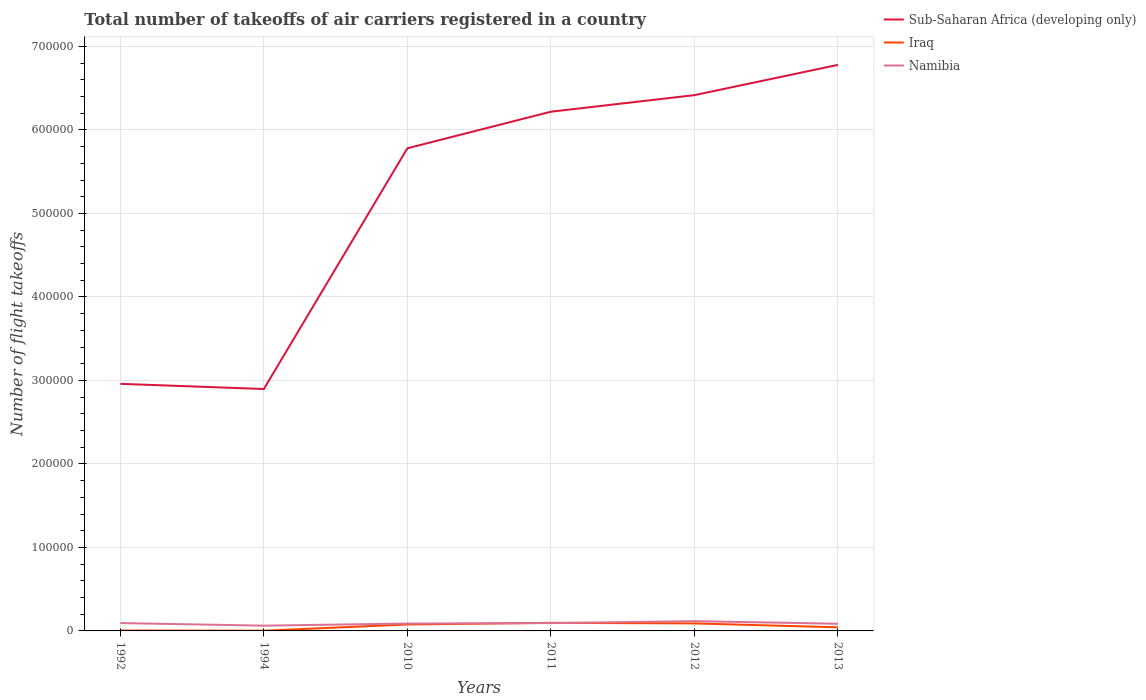How many different coloured lines are there?
Make the answer very short. 3. Across all years, what is the maximum total number of flight takeoffs in Sub-Saharan Africa (developing only)?
Ensure brevity in your answer.  2.90e+05. What is the total total number of flight takeoffs in Sub-Saharan Africa (developing only) in the graph?
Offer a terse response. -3.52e+05. What is the difference between the highest and the second highest total number of flight takeoffs in Namibia?
Offer a terse response. 5411. How many lines are there?
Make the answer very short. 3. What is the difference between two consecutive major ticks on the Y-axis?
Provide a short and direct response. 1.00e+05. Are the values on the major ticks of Y-axis written in scientific E-notation?
Your response must be concise. No. Does the graph contain any zero values?
Offer a terse response. No. Does the graph contain grids?
Your answer should be compact. Yes. Where does the legend appear in the graph?
Your answer should be compact. Top right. What is the title of the graph?
Give a very brief answer. Total number of takeoffs of air carriers registered in a country. What is the label or title of the X-axis?
Your answer should be compact. Years. What is the label or title of the Y-axis?
Give a very brief answer. Number of flight takeoffs. What is the Number of flight takeoffs of Sub-Saharan Africa (developing only) in 1992?
Provide a succinct answer. 2.96e+05. What is the Number of flight takeoffs in Iraq in 1992?
Offer a terse response. 500. What is the Number of flight takeoffs of Namibia in 1992?
Make the answer very short. 9400. What is the Number of flight takeoffs of Sub-Saharan Africa (developing only) in 1994?
Give a very brief answer. 2.90e+05. What is the Number of flight takeoffs of Iraq in 1994?
Your answer should be very brief. 300. What is the Number of flight takeoffs of Namibia in 1994?
Provide a succinct answer. 6300. What is the Number of flight takeoffs of Sub-Saharan Africa (developing only) in 2010?
Give a very brief answer. 5.78e+05. What is the Number of flight takeoffs of Iraq in 2010?
Your answer should be very brief. 7692. What is the Number of flight takeoffs of Namibia in 2010?
Your answer should be very brief. 8836. What is the Number of flight takeoffs in Sub-Saharan Africa (developing only) in 2011?
Make the answer very short. 6.22e+05. What is the Number of flight takeoffs in Iraq in 2011?
Ensure brevity in your answer.  9697. What is the Number of flight takeoffs of Namibia in 2011?
Give a very brief answer. 9400. What is the Number of flight takeoffs in Sub-Saharan Africa (developing only) in 2012?
Give a very brief answer. 6.42e+05. What is the Number of flight takeoffs of Iraq in 2012?
Provide a succinct answer. 8993. What is the Number of flight takeoffs of Namibia in 2012?
Your answer should be very brief. 1.17e+04. What is the Number of flight takeoffs of Sub-Saharan Africa (developing only) in 2013?
Provide a short and direct response. 6.78e+05. What is the Number of flight takeoffs in Iraq in 2013?
Give a very brief answer. 4320.97. What is the Number of flight takeoffs in Namibia in 2013?
Provide a short and direct response. 8571. Across all years, what is the maximum Number of flight takeoffs in Sub-Saharan Africa (developing only)?
Offer a very short reply. 6.78e+05. Across all years, what is the maximum Number of flight takeoffs in Iraq?
Offer a very short reply. 9697. Across all years, what is the maximum Number of flight takeoffs in Namibia?
Your answer should be compact. 1.17e+04. Across all years, what is the minimum Number of flight takeoffs of Sub-Saharan Africa (developing only)?
Provide a short and direct response. 2.90e+05. Across all years, what is the minimum Number of flight takeoffs in Iraq?
Provide a succinct answer. 300. Across all years, what is the minimum Number of flight takeoffs of Namibia?
Keep it short and to the point. 6300. What is the total Number of flight takeoffs of Sub-Saharan Africa (developing only) in the graph?
Give a very brief answer. 3.10e+06. What is the total Number of flight takeoffs in Iraq in the graph?
Keep it short and to the point. 3.15e+04. What is the total Number of flight takeoffs of Namibia in the graph?
Your answer should be compact. 5.42e+04. What is the difference between the Number of flight takeoffs in Sub-Saharan Africa (developing only) in 1992 and that in 1994?
Make the answer very short. 6200. What is the difference between the Number of flight takeoffs in Iraq in 1992 and that in 1994?
Provide a short and direct response. 200. What is the difference between the Number of flight takeoffs in Namibia in 1992 and that in 1994?
Offer a terse response. 3100. What is the difference between the Number of flight takeoffs of Sub-Saharan Africa (developing only) in 1992 and that in 2010?
Provide a succinct answer. -2.82e+05. What is the difference between the Number of flight takeoffs of Iraq in 1992 and that in 2010?
Ensure brevity in your answer.  -7192. What is the difference between the Number of flight takeoffs in Namibia in 1992 and that in 2010?
Ensure brevity in your answer.  564. What is the difference between the Number of flight takeoffs in Sub-Saharan Africa (developing only) in 1992 and that in 2011?
Give a very brief answer. -3.26e+05. What is the difference between the Number of flight takeoffs of Iraq in 1992 and that in 2011?
Make the answer very short. -9197. What is the difference between the Number of flight takeoffs in Sub-Saharan Africa (developing only) in 1992 and that in 2012?
Offer a terse response. -3.46e+05. What is the difference between the Number of flight takeoffs in Iraq in 1992 and that in 2012?
Offer a terse response. -8493. What is the difference between the Number of flight takeoffs in Namibia in 1992 and that in 2012?
Your response must be concise. -2311. What is the difference between the Number of flight takeoffs in Sub-Saharan Africa (developing only) in 1992 and that in 2013?
Your answer should be compact. -3.82e+05. What is the difference between the Number of flight takeoffs of Iraq in 1992 and that in 2013?
Your answer should be very brief. -3820.97. What is the difference between the Number of flight takeoffs of Namibia in 1992 and that in 2013?
Your response must be concise. 829. What is the difference between the Number of flight takeoffs in Sub-Saharan Africa (developing only) in 1994 and that in 2010?
Provide a succinct answer. -2.88e+05. What is the difference between the Number of flight takeoffs of Iraq in 1994 and that in 2010?
Offer a terse response. -7392. What is the difference between the Number of flight takeoffs of Namibia in 1994 and that in 2010?
Your answer should be very brief. -2536. What is the difference between the Number of flight takeoffs in Sub-Saharan Africa (developing only) in 1994 and that in 2011?
Your response must be concise. -3.32e+05. What is the difference between the Number of flight takeoffs in Iraq in 1994 and that in 2011?
Offer a very short reply. -9397. What is the difference between the Number of flight takeoffs in Namibia in 1994 and that in 2011?
Your answer should be very brief. -3100. What is the difference between the Number of flight takeoffs of Sub-Saharan Africa (developing only) in 1994 and that in 2012?
Your answer should be very brief. -3.52e+05. What is the difference between the Number of flight takeoffs of Iraq in 1994 and that in 2012?
Provide a short and direct response. -8693. What is the difference between the Number of flight takeoffs in Namibia in 1994 and that in 2012?
Provide a succinct answer. -5411. What is the difference between the Number of flight takeoffs of Sub-Saharan Africa (developing only) in 1994 and that in 2013?
Keep it short and to the point. -3.88e+05. What is the difference between the Number of flight takeoffs in Iraq in 1994 and that in 2013?
Your answer should be very brief. -4020.97. What is the difference between the Number of flight takeoffs in Namibia in 1994 and that in 2013?
Your answer should be compact. -2271. What is the difference between the Number of flight takeoffs of Sub-Saharan Africa (developing only) in 2010 and that in 2011?
Your answer should be compact. -4.38e+04. What is the difference between the Number of flight takeoffs in Iraq in 2010 and that in 2011?
Provide a short and direct response. -2005. What is the difference between the Number of flight takeoffs of Namibia in 2010 and that in 2011?
Give a very brief answer. -564. What is the difference between the Number of flight takeoffs of Sub-Saharan Africa (developing only) in 2010 and that in 2012?
Offer a terse response. -6.37e+04. What is the difference between the Number of flight takeoffs of Iraq in 2010 and that in 2012?
Your answer should be very brief. -1301. What is the difference between the Number of flight takeoffs of Namibia in 2010 and that in 2012?
Your response must be concise. -2875. What is the difference between the Number of flight takeoffs of Sub-Saharan Africa (developing only) in 2010 and that in 2013?
Keep it short and to the point. -9.99e+04. What is the difference between the Number of flight takeoffs of Iraq in 2010 and that in 2013?
Give a very brief answer. 3371.03. What is the difference between the Number of flight takeoffs in Namibia in 2010 and that in 2013?
Provide a succinct answer. 265. What is the difference between the Number of flight takeoffs in Sub-Saharan Africa (developing only) in 2011 and that in 2012?
Ensure brevity in your answer.  -1.98e+04. What is the difference between the Number of flight takeoffs of Iraq in 2011 and that in 2012?
Ensure brevity in your answer.  704. What is the difference between the Number of flight takeoffs in Namibia in 2011 and that in 2012?
Make the answer very short. -2311. What is the difference between the Number of flight takeoffs in Sub-Saharan Africa (developing only) in 2011 and that in 2013?
Provide a short and direct response. -5.61e+04. What is the difference between the Number of flight takeoffs of Iraq in 2011 and that in 2013?
Your response must be concise. 5376.03. What is the difference between the Number of flight takeoffs in Namibia in 2011 and that in 2013?
Make the answer very short. 829. What is the difference between the Number of flight takeoffs in Sub-Saharan Africa (developing only) in 2012 and that in 2013?
Make the answer very short. -3.62e+04. What is the difference between the Number of flight takeoffs in Iraq in 2012 and that in 2013?
Give a very brief answer. 4672.03. What is the difference between the Number of flight takeoffs in Namibia in 2012 and that in 2013?
Your answer should be compact. 3140. What is the difference between the Number of flight takeoffs in Sub-Saharan Africa (developing only) in 1992 and the Number of flight takeoffs in Iraq in 1994?
Give a very brief answer. 2.96e+05. What is the difference between the Number of flight takeoffs of Sub-Saharan Africa (developing only) in 1992 and the Number of flight takeoffs of Namibia in 1994?
Your answer should be very brief. 2.90e+05. What is the difference between the Number of flight takeoffs in Iraq in 1992 and the Number of flight takeoffs in Namibia in 1994?
Provide a short and direct response. -5800. What is the difference between the Number of flight takeoffs of Sub-Saharan Africa (developing only) in 1992 and the Number of flight takeoffs of Iraq in 2010?
Give a very brief answer. 2.88e+05. What is the difference between the Number of flight takeoffs in Sub-Saharan Africa (developing only) in 1992 and the Number of flight takeoffs in Namibia in 2010?
Make the answer very short. 2.87e+05. What is the difference between the Number of flight takeoffs of Iraq in 1992 and the Number of flight takeoffs of Namibia in 2010?
Offer a terse response. -8336. What is the difference between the Number of flight takeoffs of Sub-Saharan Africa (developing only) in 1992 and the Number of flight takeoffs of Iraq in 2011?
Your answer should be very brief. 2.86e+05. What is the difference between the Number of flight takeoffs of Sub-Saharan Africa (developing only) in 1992 and the Number of flight takeoffs of Namibia in 2011?
Provide a short and direct response. 2.86e+05. What is the difference between the Number of flight takeoffs of Iraq in 1992 and the Number of flight takeoffs of Namibia in 2011?
Your response must be concise. -8900. What is the difference between the Number of flight takeoffs of Sub-Saharan Africa (developing only) in 1992 and the Number of flight takeoffs of Iraq in 2012?
Offer a very short reply. 2.87e+05. What is the difference between the Number of flight takeoffs in Sub-Saharan Africa (developing only) in 1992 and the Number of flight takeoffs in Namibia in 2012?
Make the answer very short. 2.84e+05. What is the difference between the Number of flight takeoffs in Iraq in 1992 and the Number of flight takeoffs in Namibia in 2012?
Provide a short and direct response. -1.12e+04. What is the difference between the Number of flight takeoffs of Sub-Saharan Africa (developing only) in 1992 and the Number of flight takeoffs of Iraq in 2013?
Give a very brief answer. 2.92e+05. What is the difference between the Number of flight takeoffs of Sub-Saharan Africa (developing only) in 1992 and the Number of flight takeoffs of Namibia in 2013?
Your answer should be very brief. 2.87e+05. What is the difference between the Number of flight takeoffs in Iraq in 1992 and the Number of flight takeoffs in Namibia in 2013?
Ensure brevity in your answer.  -8071. What is the difference between the Number of flight takeoffs in Sub-Saharan Africa (developing only) in 1994 and the Number of flight takeoffs in Iraq in 2010?
Offer a terse response. 2.82e+05. What is the difference between the Number of flight takeoffs in Sub-Saharan Africa (developing only) in 1994 and the Number of flight takeoffs in Namibia in 2010?
Keep it short and to the point. 2.81e+05. What is the difference between the Number of flight takeoffs in Iraq in 1994 and the Number of flight takeoffs in Namibia in 2010?
Ensure brevity in your answer.  -8536. What is the difference between the Number of flight takeoffs in Sub-Saharan Africa (developing only) in 1994 and the Number of flight takeoffs in Iraq in 2011?
Offer a terse response. 2.80e+05. What is the difference between the Number of flight takeoffs of Sub-Saharan Africa (developing only) in 1994 and the Number of flight takeoffs of Namibia in 2011?
Ensure brevity in your answer.  2.80e+05. What is the difference between the Number of flight takeoffs of Iraq in 1994 and the Number of flight takeoffs of Namibia in 2011?
Your answer should be compact. -9100. What is the difference between the Number of flight takeoffs in Sub-Saharan Africa (developing only) in 1994 and the Number of flight takeoffs in Iraq in 2012?
Provide a short and direct response. 2.81e+05. What is the difference between the Number of flight takeoffs of Sub-Saharan Africa (developing only) in 1994 and the Number of flight takeoffs of Namibia in 2012?
Keep it short and to the point. 2.78e+05. What is the difference between the Number of flight takeoffs of Iraq in 1994 and the Number of flight takeoffs of Namibia in 2012?
Provide a succinct answer. -1.14e+04. What is the difference between the Number of flight takeoffs in Sub-Saharan Africa (developing only) in 1994 and the Number of flight takeoffs in Iraq in 2013?
Make the answer very short. 2.85e+05. What is the difference between the Number of flight takeoffs in Sub-Saharan Africa (developing only) in 1994 and the Number of flight takeoffs in Namibia in 2013?
Ensure brevity in your answer.  2.81e+05. What is the difference between the Number of flight takeoffs of Iraq in 1994 and the Number of flight takeoffs of Namibia in 2013?
Make the answer very short. -8271. What is the difference between the Number of flight takeoffs in Sub-Saharan Africa (developing only) in 2010 and the Number of flight takeoffs in Iraq in 2011?
Offer a terse response. 5.68e+05. What is the difference between the Number of flight takeoffs in Sub-Saharan Africa (developing only) in 2010 and the Number of flight takeoffs in Namibia in 2011?
Ensure brevity in your answer.  5.69e+05. What is the difference between the Number of flight takeoffs in Iraq in 2010 and the Number of flight takeoffs in Namibia in 2011?
Provide a succinct answer. -1708. What is the difference between the Number of flight takeoffs in Sub-Saharan Africa (developing only) in 2010 and the Number of flight takeoffs in Iraq in 2012?
Your response must be concise. 5.69e+05. What is the difference between the Number of flight takeoffs of Sub-Saharan Africa (developing only) in 2010 and the Number of flight takeoffs of Namibia in 2012?
Give a very brief answer. 5.66e+05. What is the difference between the Number of flight takeoffs of Iraq in 2010 and the Number of flight takeoffs of Namibia in 2012?
Make the answer very short. -4019. What is the difference between the Number of flight takeoffs of Sub-Saharan Africa (developing only) in 2010 and the Number of flight takeoffs of Iraq in 2013?
Offer a very short reply. 5.74e+05. What is the difference between the Number of flight takeoffs in Sub-Saharan Africa (developing only) in 2010 and the Number of flight takeoffs in Namibia in 2013?
Your answer should be very brief. 5.69e+05. What is the difference between the Number of flight takeoffs in Iraq in 2010 and the Number of flight takeoffs in Namibia in 2013?
Provide a succinct answer. -879. What is the difference between the Number of flight takeoffs in Sub-Saharan Africa (developing only) in 2011 and the Number of flight takeoffs in Iraq in 2012?
Your answer should be very brief. 6.13e+05. What is the difference between the Number of flight takeoffs in Sub-Saharan Africa (developing only) in 2011 and the Number of flight takeoffs in Namibia in 2012?
Make the answer very short. 6.10e+05. What is the difference between the Number of flight takeoffs in Iraq in 2011 and the Number of flight takeoffs in Namibia in 2012?
Your response must be concise. -2014. What is the difference between the Number of flight takeoffs in Sub-Saharan Africa (developing only) in 2011 and the Number of flight takeoffs in Iraq in 2013?
Your response must be concise. 6.17e+05. What is the difference between the Number of flight takeoffs of Sub-Saharan Africa (developing only) in 2011 and the Number of flight takeoffs of Namibia in 2013?
Your answer should be very brief. 6.13e+05. What is the difference between the Number of flight takeoffs in Iraq in 2011 and the Number of flight takeoffs in Namibia in 2013?
Your response must be concise. 1126. What is the difference between the Number of flight takeoffs in Sub-Saharan Africa (developing only) in 2012 and the Number of flight takeoffs in Iraq in 2013?
Make the answer very short. 6.37e+05. What is the difference between the Number of flight takeoffs of Sub-Saharan Africa (developing only) in 2012 and the Number of flight takeoffs of Namibia in 2013?
Ensure brevity in your answer.  6.33e+05. What is the difference between the Number of flight takeoffs of Iraq in 2012 and the Number of flight takeoffs of Namibia in 2013?
Make the answer very short. 422. What is the average Number of flight takeoffs in Sub-Saharan Africa (developing only) per year?
Your answer should be compact. 5.17e+05. What is the average Number of flight takeoffs of Iraq per year?
Provide a succinct answer. 5250.5. What is the average Number of flight takeoffs of Namibia per year?
Give a very brief answer. 9036.33. In the year 1992, what is the difference between the Number of flight takeoffs of Sub-Saharan Africa (developing only) and Number of flight takeoffs of Iraq?
Your answer should be very brief. 2.95e+05. In the year 1992, what is the difference between the Number of flight takeoffs of Sub-Saharan Africa (developing only) and Number of flight takeoffs of Namibia?
Provide a short and direct response. 2.86e+05. In the year 1992, what is the difference between the Number of flight takeoffs of Iraq and Number of flight takeoffs of Namibia?
Ensure brevity in your answer.  -8900. In the year 1994, what is the difference between the Number of flight takeoffs of Sub-Saharan Africa (developing only) and Number of flight takeoffs of Iraq?
Your answer should be very brief. 2.89e+05. In the year 1994, what is the difference between the Number of flight takeoffs in Sub-Saharan Africa (developing only) and Number of flight takeoffs in Namibia?
Provide a succinct answer. 2.83e+05. In the year 1994, what is the difference between the Number of flight takeoffs of Iraq and Number of flight takeoffs of Namibia?
Your response must be concise. -6000. In the year 2010, what is the difference between the Number of flight takeoffs of Sub-Saharan Africa (developing only) and Number of flight takeoffs of Iraq?
Keep it short and to the point. 5.70e+05. In the year 2010, what is the difference between the Number of flight takeoffs of Sub-Saharan Africa (developing only) and Number of flight takeoffs of Namibia?
Your answer should be very brief. 5.69e+05. In the year 2010, what is the difference between the Number of flight takeoffs of Iraq and Number of flight takeoffs of Namibia?
Your answer should be very brief. -1144. In the year 2011, what is the difference between the Number of flight takeoffs of Sub-Saharan Africa (developing only) and Number of flight takeoffs of Iraq?
Make the answer very short. 6.12e+05. In the year 2011, what is the difference between the Number of flight takeoffs in Sub-Saharan Africa (developing only) and Number of flight takeoffs in Namibia?
Keep it short and to the point. 6.12e+05. In the year 2011, what is the difference between the Number of flight takeoffs of Iraq and Number of flight takeoffs of Namibia?
Give a very brief answer. 297. In the year 2012, what is the difference between the Number of flight takeoffs of Sub-Saharan Africa (developing only) and Number of flight takeoffs of Iraq?
Keep it short and to the point. 6.33e+05. In the year 2012, what is the difference between the Number of flight takeoffs in Sub-Saharan Africa (developing only) and Number of flight takeoffs in Namibia?
Make the answer very short. 6.30e+05. In the year 2012, what is the difference between the Number of flight takeoffs in Iraq and Number of flight takeoffs in Namibia?
Offer a terse response. -2718. In the year 2013, what is the difference between the Number of flight takeoffs of Sub-Saharan Africa (developing only) and Number of flight takeoffs of Iraq?
Offer a very short reply. 6.74e+05. In the year 2013, what is the difference between the Number of flight takeoffs of Sub-Saharan Africa (developing only) and Number of flight takeoffs of Namibia?
Your response must be concise. 6.69e+05. In the year 2013, what is the difference between the Number of flight takeoffs in Iraq and Number of flight takeoffs in Namibia?
Make the answer very short. -4250.03. What is the ratio of the Number of flight takeoffs of Sub-Saharan Africa (developing only) in 1992 to that in 1994?
Ensure brevity in your answer.  1.02. What is the ratio of the Number of flight takeoffs in Namibia in 1992 to that in 1994?
Your answer should be compact. 1.49. What is the ratio of the Number of flight takeoffs of Sub-Saharan Africa (developing only) in 1992 to that in 2010?
Offer a terse response. 0.51. What is the ratio of the Number of flight takeoffs in Iraq in 1992 to that in 2010?
Provide a short and direct response. 0.07. What is the ratio of the Number of flight takeoffs of Namibia in 1992 to that in 2010?
Provide a short and direct response. 1.06. What is the ratio of the Number of flight takeoffs of Sub-Saharan Africa (developing only) in 1992 to that in 2011?
Offer a very short reply. 0.48. What is the ratio of the Number of flight takeoffs in Iraq in 1992 to that in 2011?
Keep it short and to the point. 0.05. What is the ratio of the Number of flight takeoffs of Namibia in 1992 to that in 2011?
Offer a terse response. 1. What is the ratio of the Number of flight takeoffs in Sub-Saharan Africa (developing only) in 1992 to that in 2012?
Your answer should be compact. 0.46. What is the ratio of the Number of flight takeoffs of Iraq in 1992 to that in 2012?
Make the answer very short. 0.06. What is the ratio of the Number of flight takeoffs in Namibia in 1992 to that in 2012?
Offer a very short reply. 0.8. What is the ratio of the Number of flight takeoffs of Sub-Saharan Africa (developing only) in 1992 to that in 2013?
Offer a terse response. 0.44. What is the ratio of the Number of flight takeoffs of Iraq in 1992 to that in 2013?
Ensure brevity in your answer.  0.12. What is the ratio of the Number of flight takeoffs in Namibia in 1992 to that in 2013?
Provide a short and direct response. 1.1. What is the ratio of the Number of flight takeoffs of Sub-Saharan Africa (developing only) in 1994 to that in 2010?
Offer a very short reply. 0.5. What is the ratio of the Number of flight takeoffs of Iraq in 1994 to that in 2010?
Your response must be concise. 0.04. What is the ratio of the Number of flight takeoffs of Namibia in 1994 to that in 2010?
Your answer should be very brief. 0.71. What is the ratio of the Number of flight takeoffs of Sub-Saharan Africa (developing only) in 1994 to that in 2011?
Offer a terse response. 0.47. What is the ratio of the Number of flight takeoffs of Iraq in 1994 to that in 2011?
Your answer should be very brief. 0.03. What is the ratio of the Number of flight takeoffs of Namibia in 1994 to that in 2011?
Make the answer very short. 0.67. What is the ratio of the Number of flight takeoffs of Sub-Saharan Africa (developing only) in 1994 to that in 2012?
Ensure brevity in your answer.  0.45. What is the ratio of the Number of flight takeoffs of Iraq in 1994 to that in 2012?
Provide a succinct answer. 0.03. What is the ratio of the Number of flight takeoffs in Namibia in 1994 to that in 2012?
Your answer should be very brief. 0.54. What is the ratio of the Number of flight takeoffs in Sub-Saharan Africa (developing only) in 1994 to that in 2013?
Offer a very short reply. 0.43. What is the ratio of the Number of flight takeoffs in Iraq in 1994 to that in 2013?
Give a very brief answer. 0.07. What is the ratio of the Number of flight takeoffs in Namibia in 1994 to that in 2013?
Ensure brevity in your answer.  0.73. What is the ratio of the Number of flight takeoffs in Sub-Saharan Africa (developing only) in 2010 to that in 2011?
Your answer should be very brief. 0.93. What is the ratio of the Number of flight takeoffs in Iraq in 2010 to that in 2011?
Keep it short and to the point. 0.79. What is the ratio of the Number of flight takeoffs of Namibia in 2010 to that in 2011?
Give a very brief answer. 0.94. What is the ratio of the Number of flight takeoffs in Sub-Saharan Africa (developing only) in 2010 to that in 2012?
Your answer should be compact. 0.9. What is the ratio of the Number of flight takeoffs in Iraq in 2010 to that in 2012?
Offer a terse response. 0.86. What is the ratio of the Number of flight takeoffs in Namibia in 2010 to that in 2012?
Make the answer very short. 0.75. What is the ratio of the Number of flight takeoffs in Sub-Saharan Africa (developing only) in 2010 to that in 2013?
Your response must be concise. 0.85. What is the ratio of the Number of flight takeoffs of Iraq in 2010 to that in 2013?
Make the answer very short. 1.78. What is the ratio of the Number of flight takeoffs in Namibia in 2010 to that in 2013?
Offer a terse response. 1.03. What is the ratio of the Number of flight takeoffs of Sub-Saharan Africa (developing only) in 2011 to that in 2012?
Provide a short and direct response. 0.97. What is the ratio of the Number of flight takeoffs in Iraq in 2011 to that in 2012?
Offer a very short reply. 1.08. What is the ratio of the Number of flight takeoffs of Namibia in 2011 to that in 2012?
Provide a short and direct response. 0.8. What is the ratio of the Number of flight takeoffs of Sub-Saharan Africa (developing only) in 2011 to that in 2013?
Your response must be concise. 0.92. What is the ratio of the Number of flight takeoffs of Iraq in 2011 to that in 2013?
Your answer should be compact. 2.24. What is the ratio of the Number of flight takeoffs in Namibia in 2011 to that in 2013?
Give a very brief answer. 1.1. What is the ratio of the Number of flight takeoffs in Sub-Saharan Africa (developing only) in 2012 to that in 2013?
Offer a terse response. 0.95. What is the ratio of the Number of flight takeoffs in Iraq in 2012 to that in 2013?
Your answer should be compact. 2.08. What is the ratio of the Number of flight takeoffs in Namibia in 2012 to that in 2013?
Offer a very short reply. 1.37. What is the difference between the highest and the second highest Number of flight takeoffs in Sub-Saharan Africa (developing only)?
Your response must be concise. 3.62e+04. What is the difference between the highest and the second highest Number of flight takeoffs in Iraq?
Provide a succinct answer. 704. What is the difference between the highest and the second highest Number of flight takeoffs of Namibia?
Provide a short and direct response. 2311. What is the difference between the highest and the lowest Number of flight takeoffs of Sub-Saharan Africa (developing only)?
Offer a very short reply. 3.88e+05. What is the difference between the highest and the lowest Number of flight takeoffs of Iraq?
Keep it short and to the point. 9397. What is the difference between the highest and the lowest Number of flight takeoffs of Namibia?
Ensure brevity in your answer.  5411. 